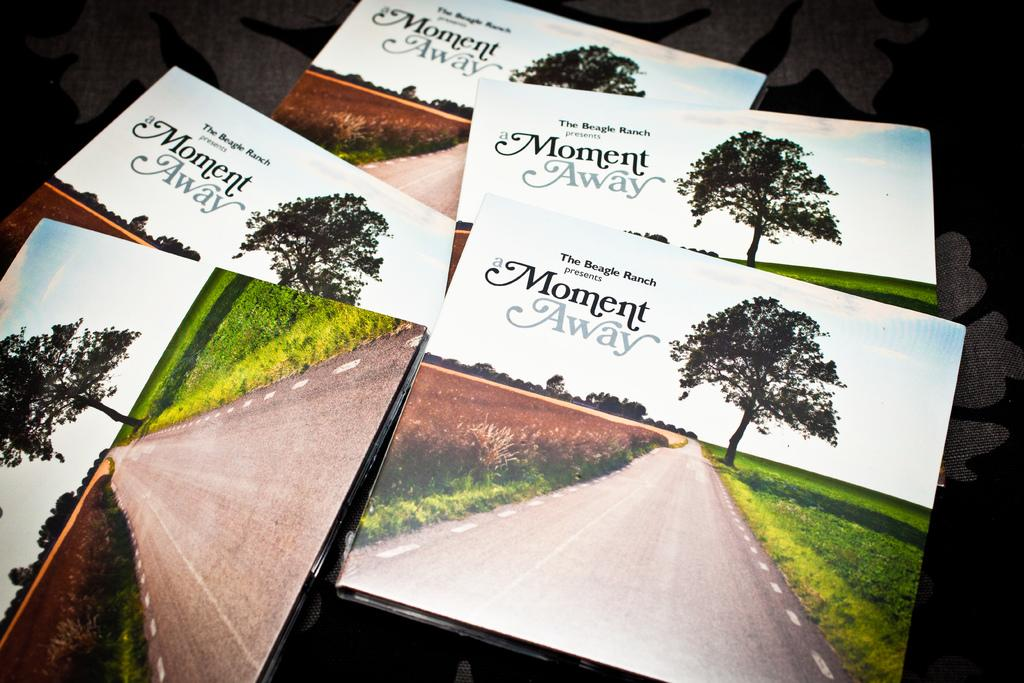What objects are on the surface in the image? There are books on a surface in the image. What is the common feature of the books? The books have the same picture on them. What elements can be seen in the picture on the books? The picture on the books contains a tree, a road, and grass. What type of property is visible in the image? There is no property visible in the image; it features books with a picture on them. What suggestion can be made based on the picture on the books? The image does not provide any suggestions; it only shows books with a picture on them. Can you tell me where the throne is located in the image? There is no throne present in the image. 